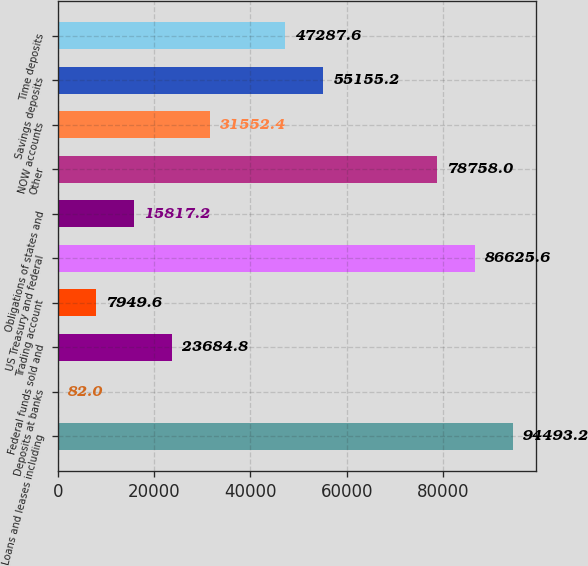Convert chart. <chart><loc_0><loc_0><loc_500><loc_500><bar_chart><fcel>Loans and leases including<fcel>Deposits at banks<fcel>Federal funds sold and<fcel>Trading account<fcel>US Treasury and federal<fcel>Obligations of states and<fcel>Other<fcel>NOW accounts<fcel>Savings deposits<fcel>Time deposits<nl><fcel>94493.2<fcel>82<fcel>23684.8<fcel>7949.6<fcel>86625.6<fcel>15817.2<fcel>78758<fcel>31552.4<fcel>55155.2<fcel>47287.6<nl></chart> 